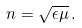<formula> <loc_0><loc_0><loc_500><loc_500>n = \sqrt { \epsilon \mu } \, .</formula> 